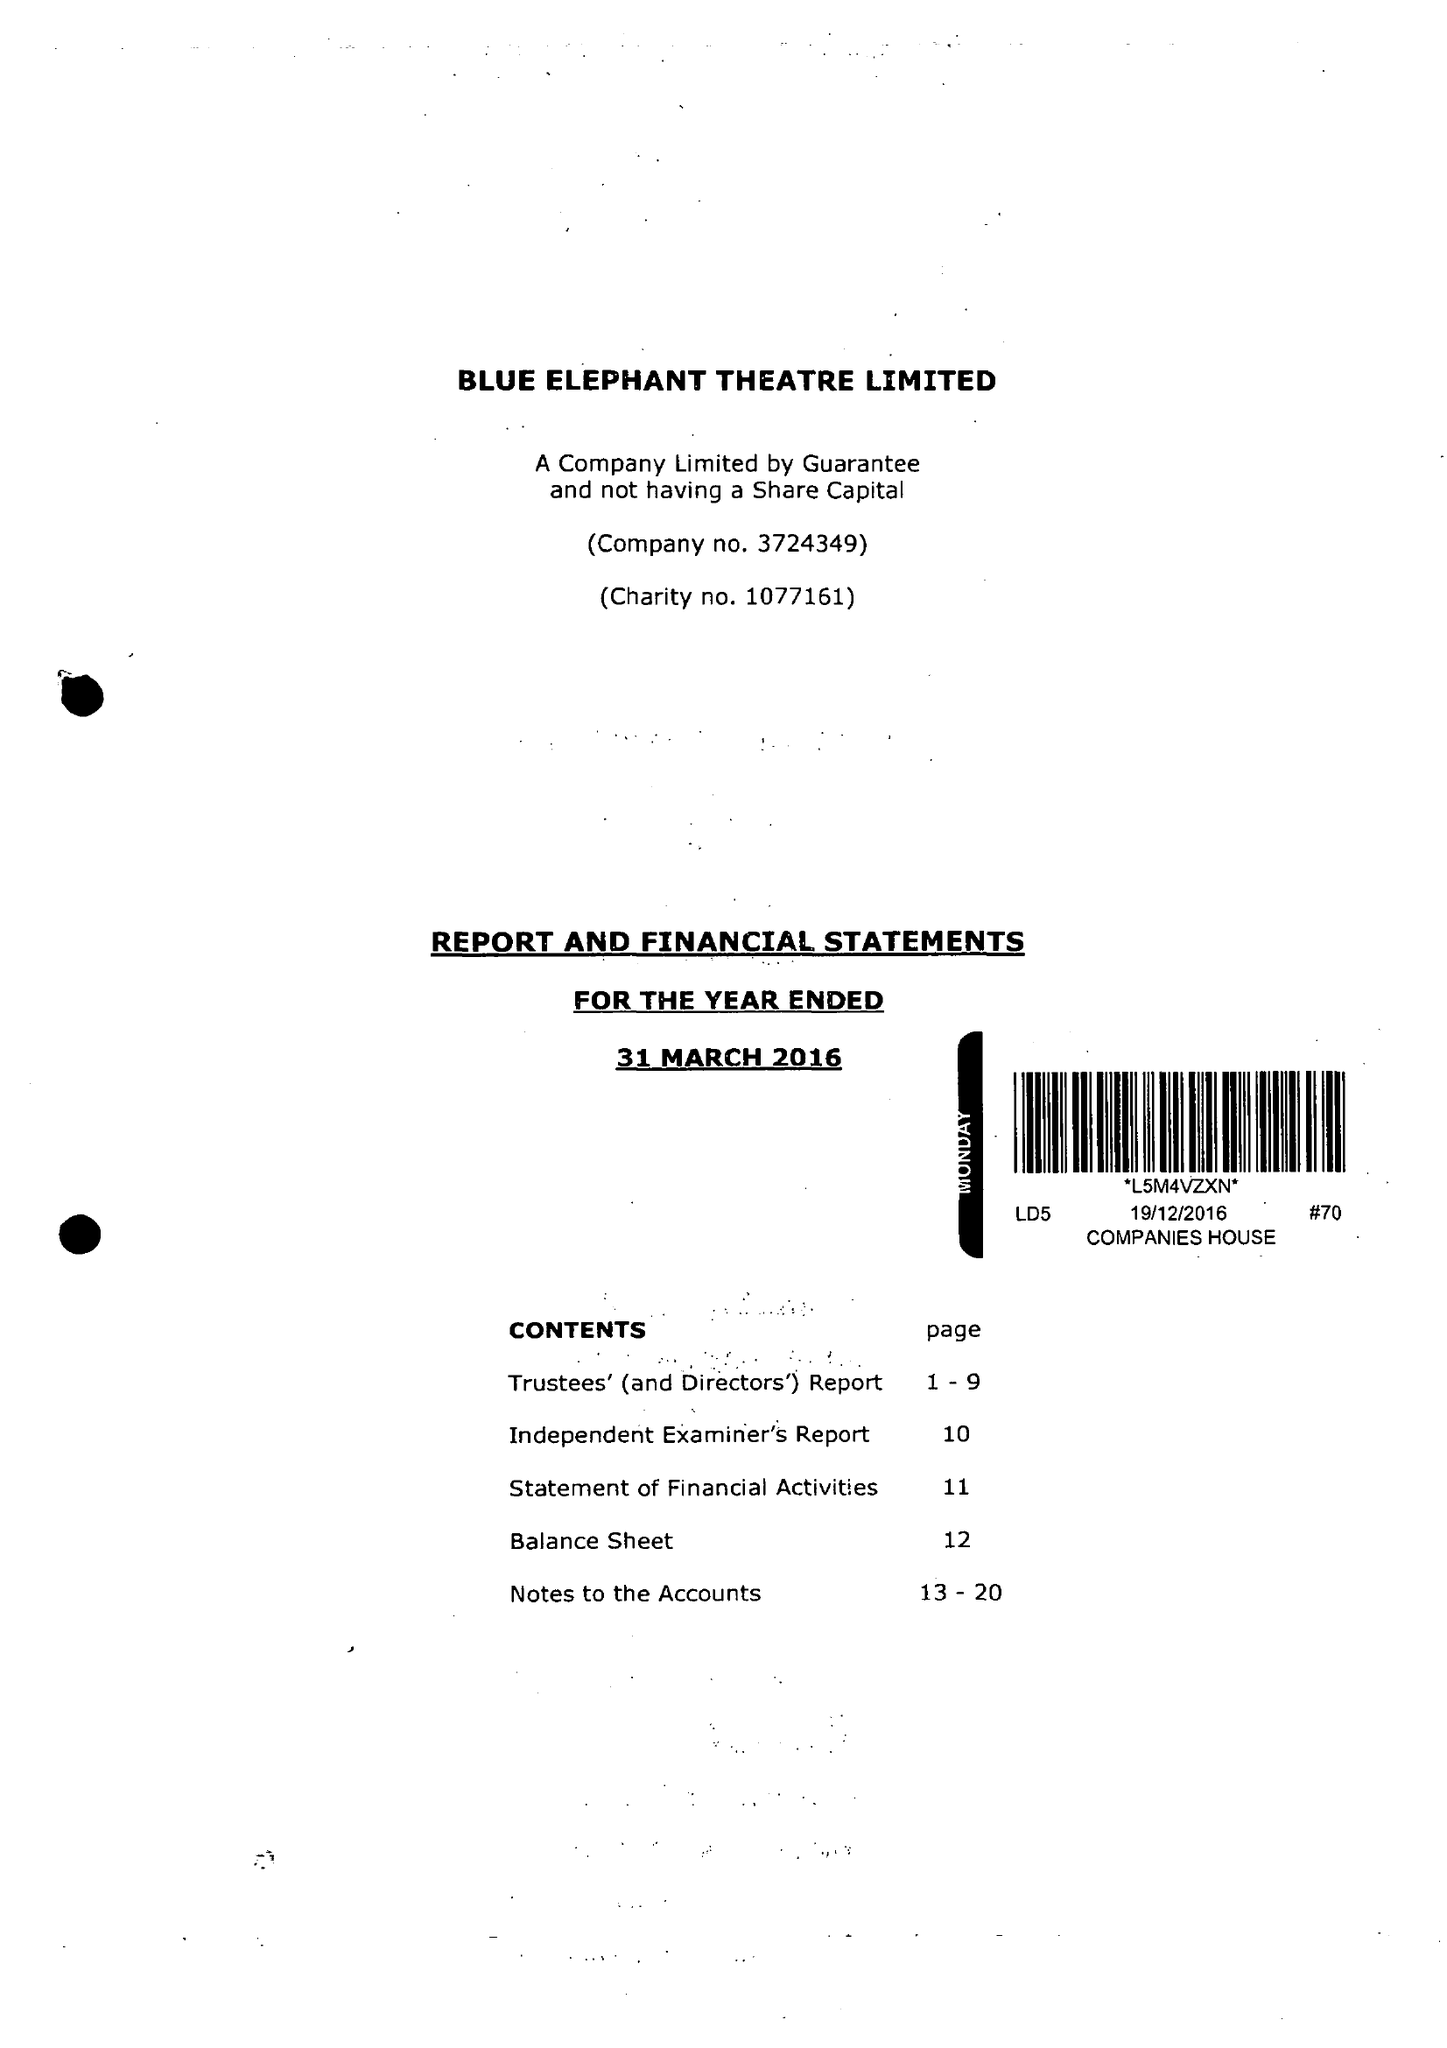What is the value for the spending_annually_in_british_pounds?
Answer the question using a single word or phrase. 143665.00 